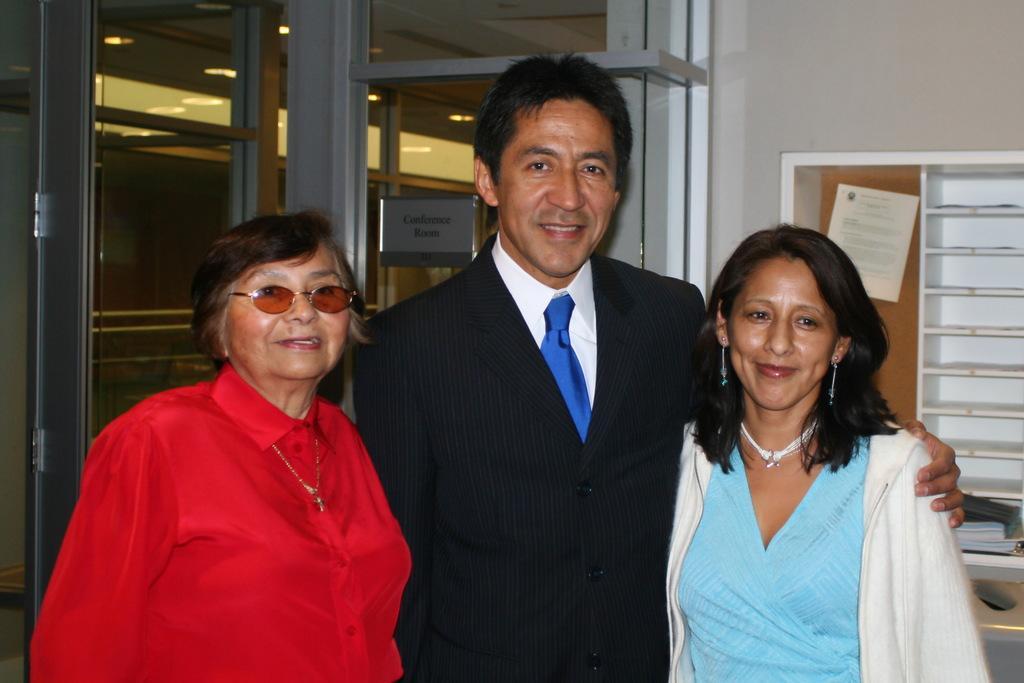Could you give a brief overview of what you see in this image? In the image there are three people standing in the foreground and posing for the photo, behind them there are two doors and on the right side there is an object, in front of the object it seems like there are two books. 